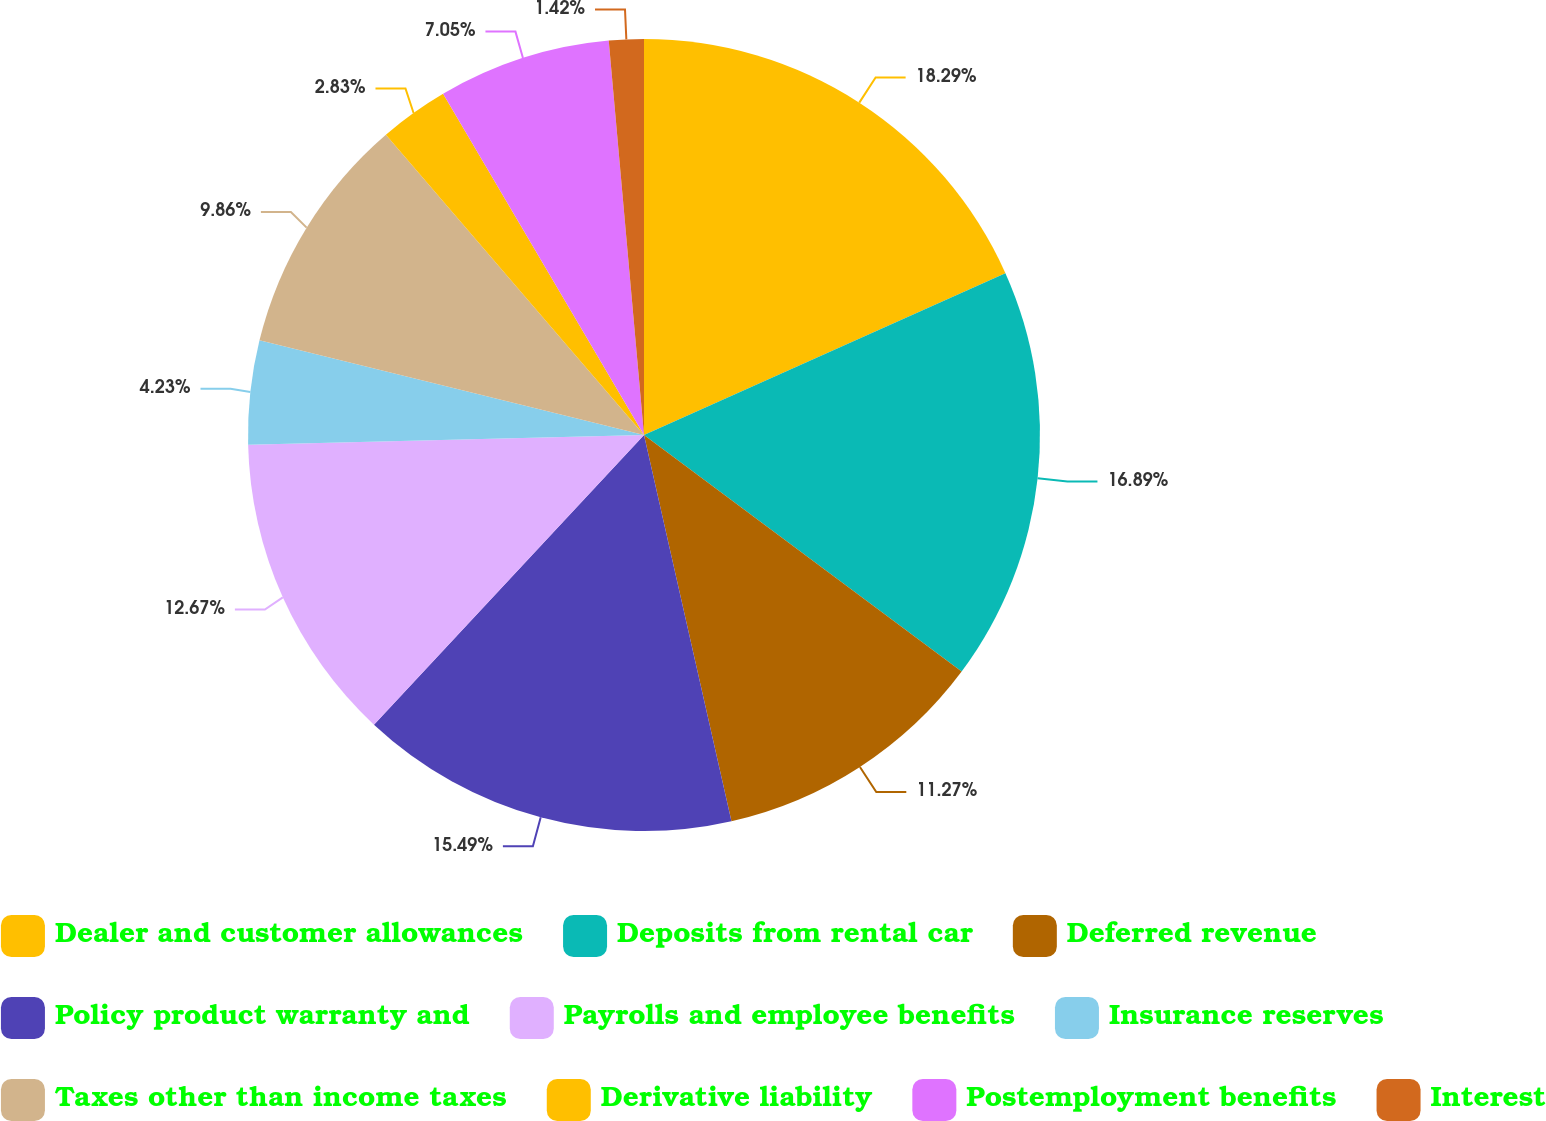<chart> <loc_0><loc_0><loc_500><loc_500><pie_chart><fcel>Dealer and customer allowances<fcel>Deposits from rental car<fcel>Deferred revenue<fcel>Policy product warranty and<fcel>Payrolls and employee benefits<fcel>Insurance reserves<fcel>Taxes other than income taxes<fcel>Derivative liability<fcel>Postemployment benefits<fcel>Interest<nl><fcel>18.3%<fcel>16.89%<fcel>11.27%<fcel>15.49%<fcel>12.67%<fcel>4.23%<fcel>9.86%<fcel>2.83%<fcel>7.05%<fcel>1.42%<nl></chart> 